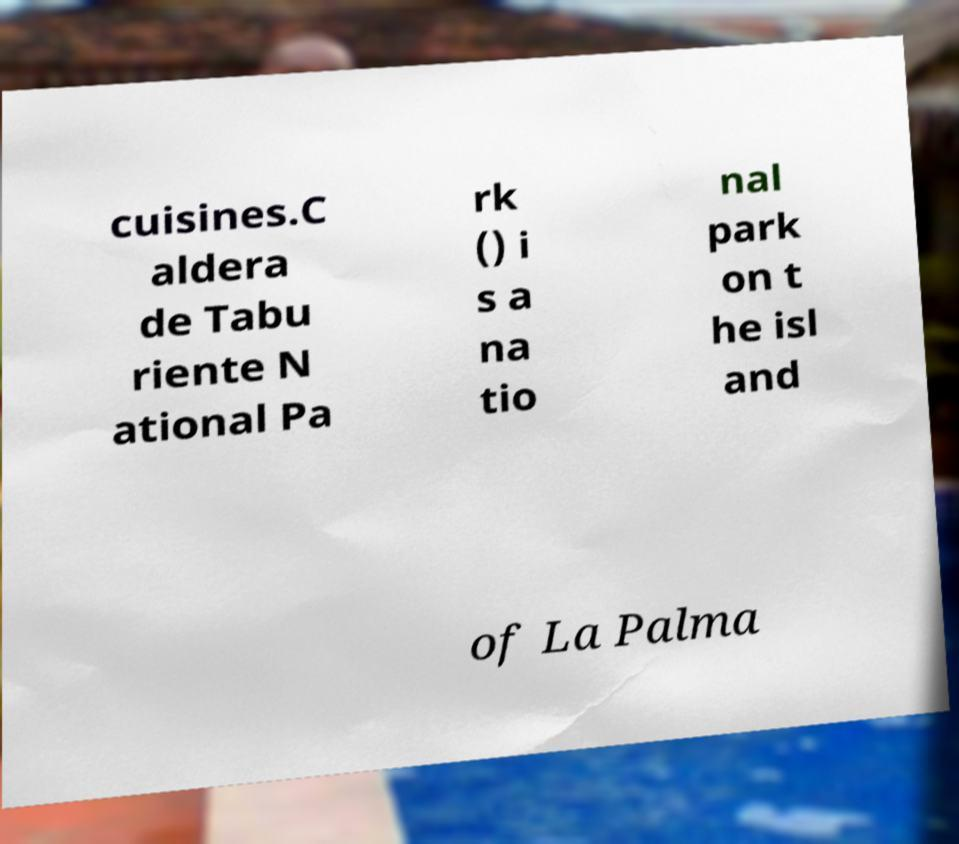Could you assist in decoding the text presented in this image and type it out clearly? cuisines.C aldera de Tabu riente N ational Pa rk () i s a na tio nal park on t he isl and of La Palma 